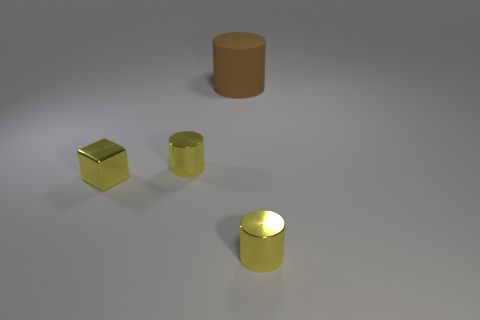Add 3 purple matte balls. How many objects exist? 7 Subtract all cylinders. How many objects are left? 1 Subtract all gray shiny objects. Subtract all yellow shiny cylinders. How many objects are left? 2 Add 1 yellow metal objects. How many yellow metal objects are left? 4 Add 2 big brown cylinders. How many big brown cylinders exist? 3 Subtract 0 purple spheres. How many objects are left? 4 